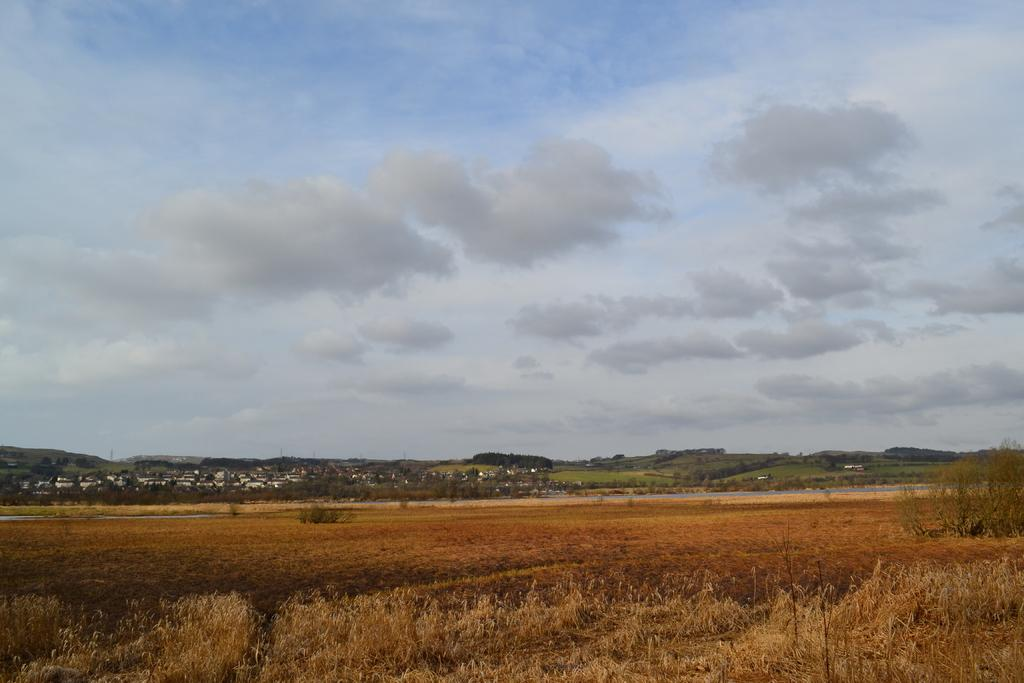What is visible in the background of the image? The sky is visible in the image. What can be seen in the sky in the image? There are clouds in the image. What type of vegetation is present in the image? Grass is present in the image. What type of natural structures are visible in the image? There are trees in the image. What type of man-made structures are visible in the image? There are buildings and houses in the image. How does the daughter feel about her income in the image? There is no daughter or mention of income present in the image. What type of shame is depicted in the image? There is no shame or any emotional state depicted in the image. 